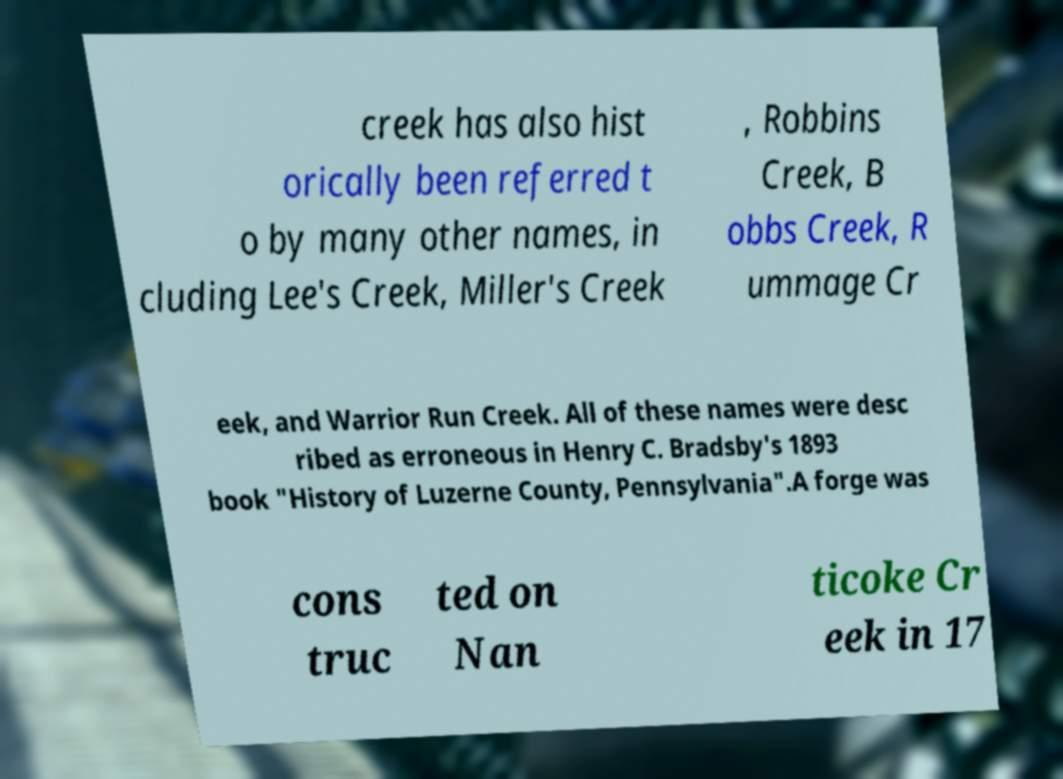Could you assist in decoding the text presented in this image and type it out clearly? creek has also hist orically been referred t o by many other names, in cluding Lee's Creek, Miller's Creek , Robbins Creek, B obbs Creek, R ummage Cr eek, and Warrior Run Creek. All of these names were desc ribed as erroneous in Henry C. Bradsby's 1893 book "History of Luzerne County, Pennsylvania".A forge was cons truc ted on Nan ticoke Cr eek in 17 